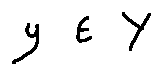<formula> <loc_0><loc_0><loc_500><loc_500>y \in Y</formula> 